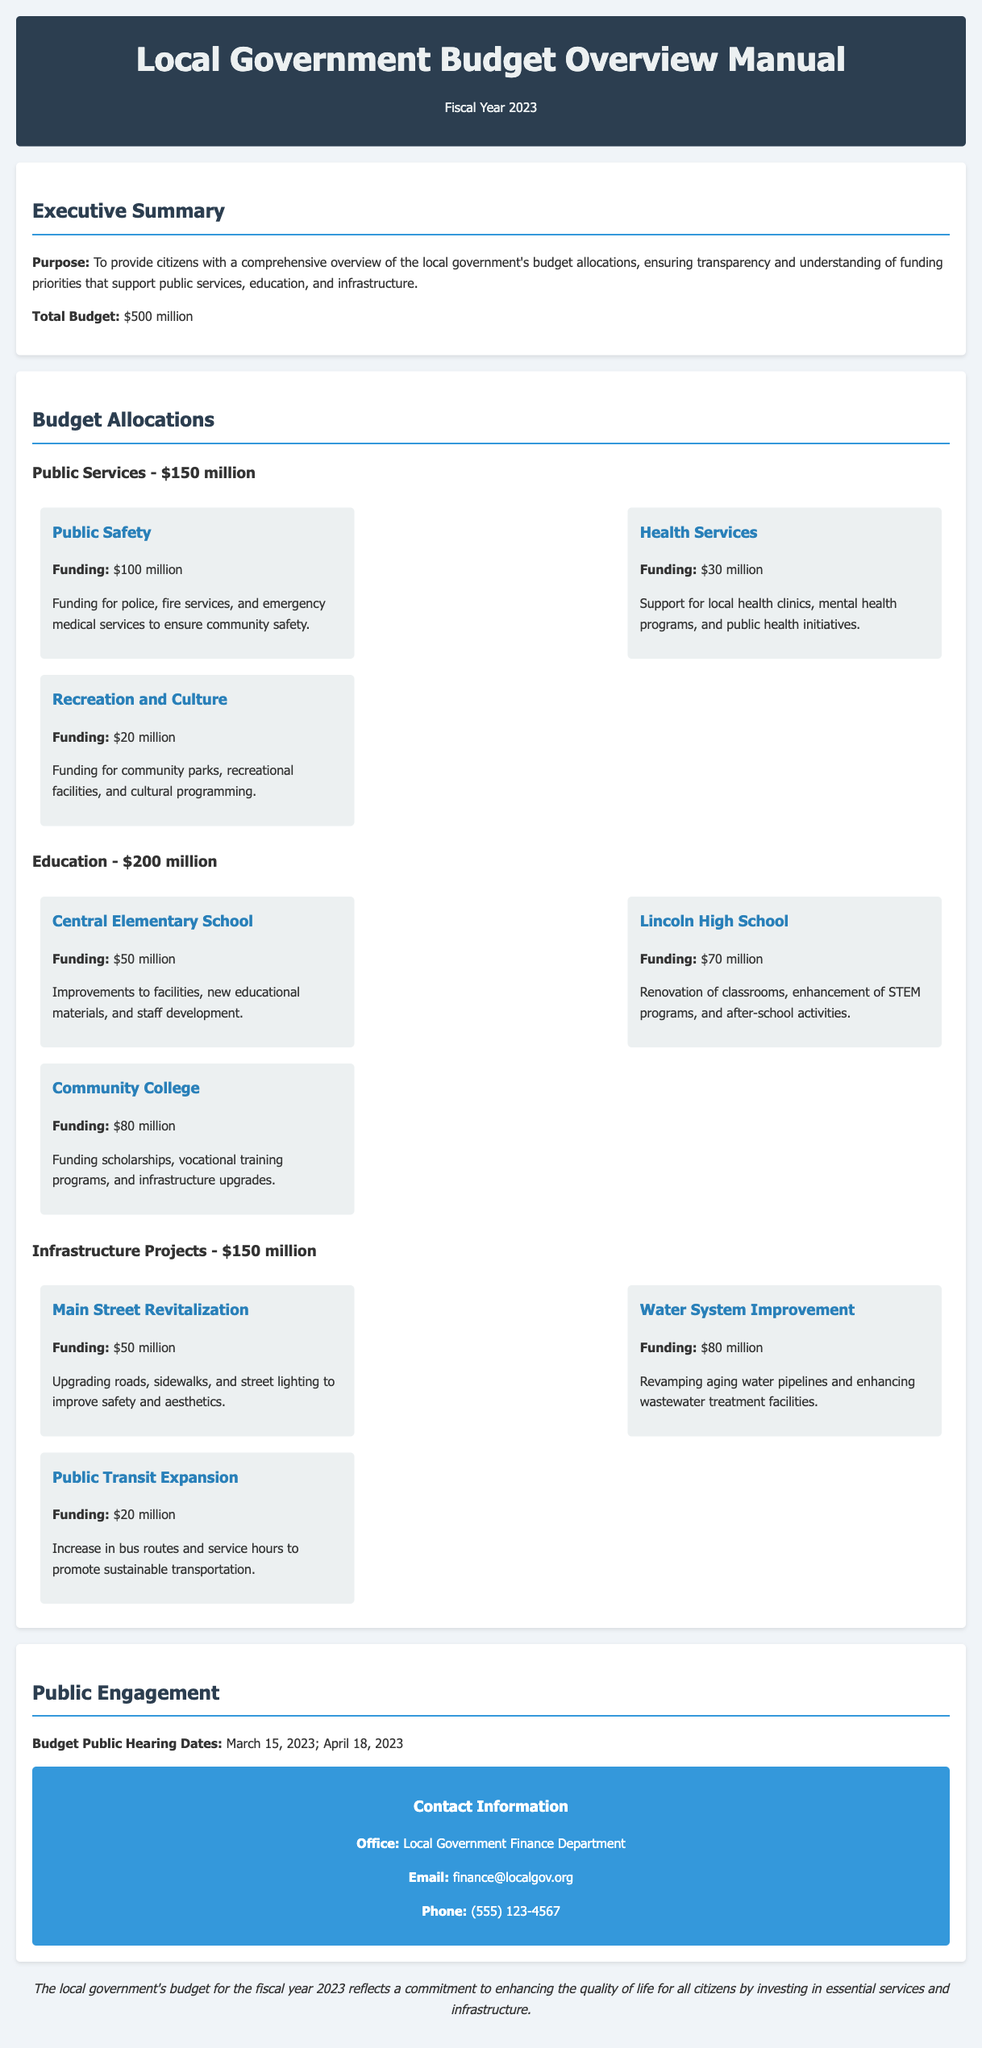what is the total budget for the fiscal year 2023? The total budget is explicitly stated in the Executive Summary section of the document.
Answer: $500 million how much funding is allocated for public safety? The specific funding amount for public safety is mentioned under the Public Services section.
Answer: $100 million what are the budget public hearing dates? The dates for the budget public hearings are listed in the Public Engagement section.
Answer: March 15, 2023; April 18, 2023 how much funding does Lincoln High School receive? This specific funding amount is provided in the Education section of the budget allocations.
Answer: $70 million which project receives the largest allocation under infrastructure projects? The project with the largest allocation is identifiable due to its funding details presented in the Infrastructure Projects section.
Answer: Water System Improvement what is the purpose of the local government budget overview manual? The purpose is given in the Executive Summary section, elaborating on the goals of transparency and understanding of budget priorities.
Answer: To provide citizens with a comprehensive overview how much funding is dedicated to health services? The allocation for health services can be found under the Public Services budget allocations in the document.
Answer: $30 million who should be contacted for inquiries regarding the budget? The contact information is available in the Public Engagement section, specifying the responsible department.
Answer: Local Government Finance Department 